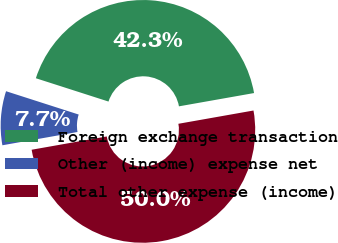<chart> <loc_0><loc_0><loc_500><loc_500><pie_chart><fcel>Foreign exchange transaction<fcel>Other (income) expense net<fcel>Total other expense (income)<nl><fcel>42.27%<fcel>7.73%<fcel>50.0%<nl></chart> 